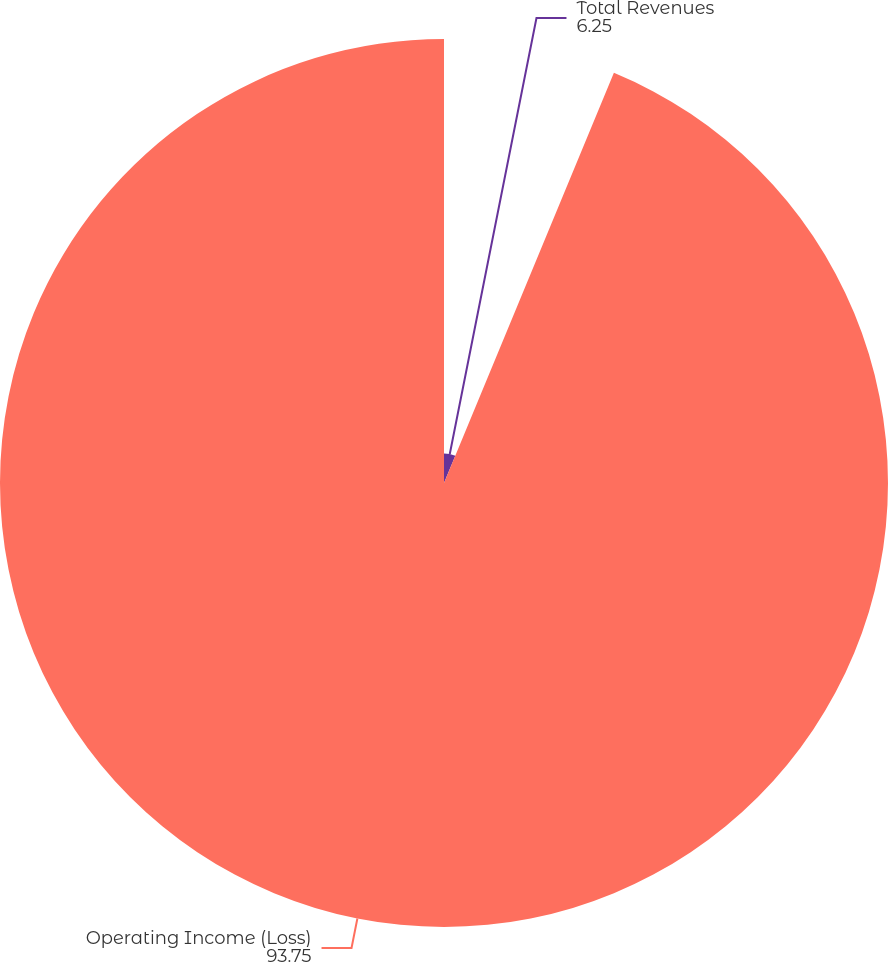Convert chart. <chart><loc_0><loc_0><loc_500><loc_500><pie_chart><fcel>Total Revenues<fcel>Operating Income (Loss)<nl><fcel>6.25%<fcel>93.75%<nl></chart> 